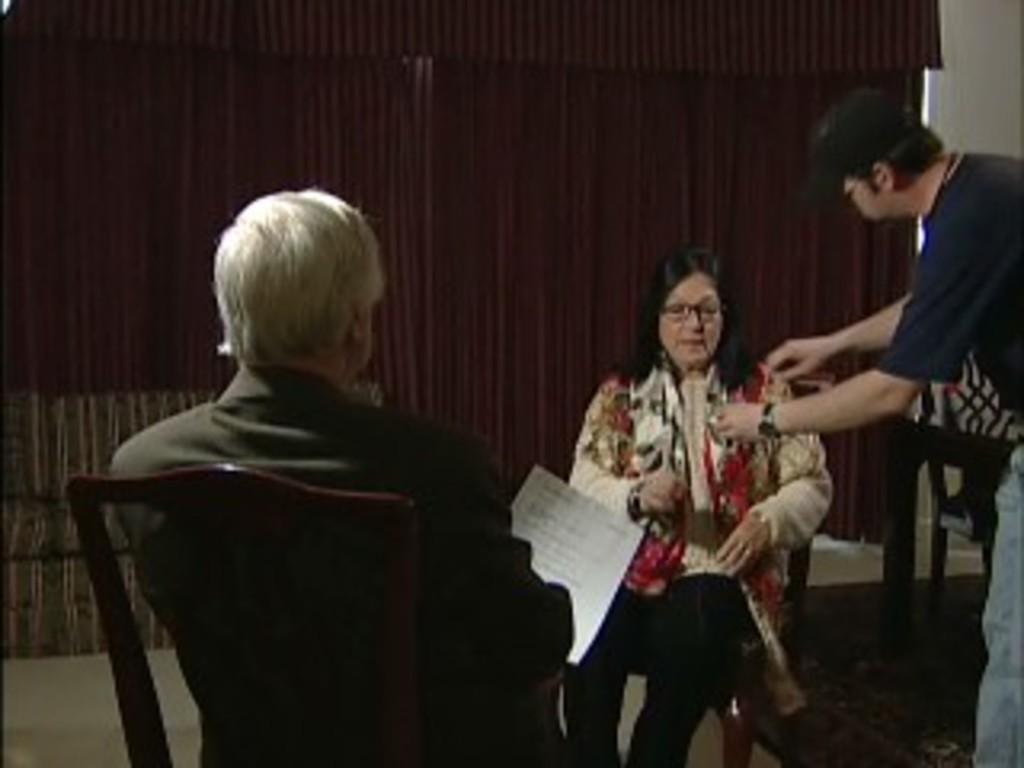Please provide a concise description of this image. In this image there are three persons. At the right side the man is standing and is helping a woman in the center who is sitting on a chair. At the left side the man is sitting on the chair is holding a paper in his hand. In the background there are curtains. 